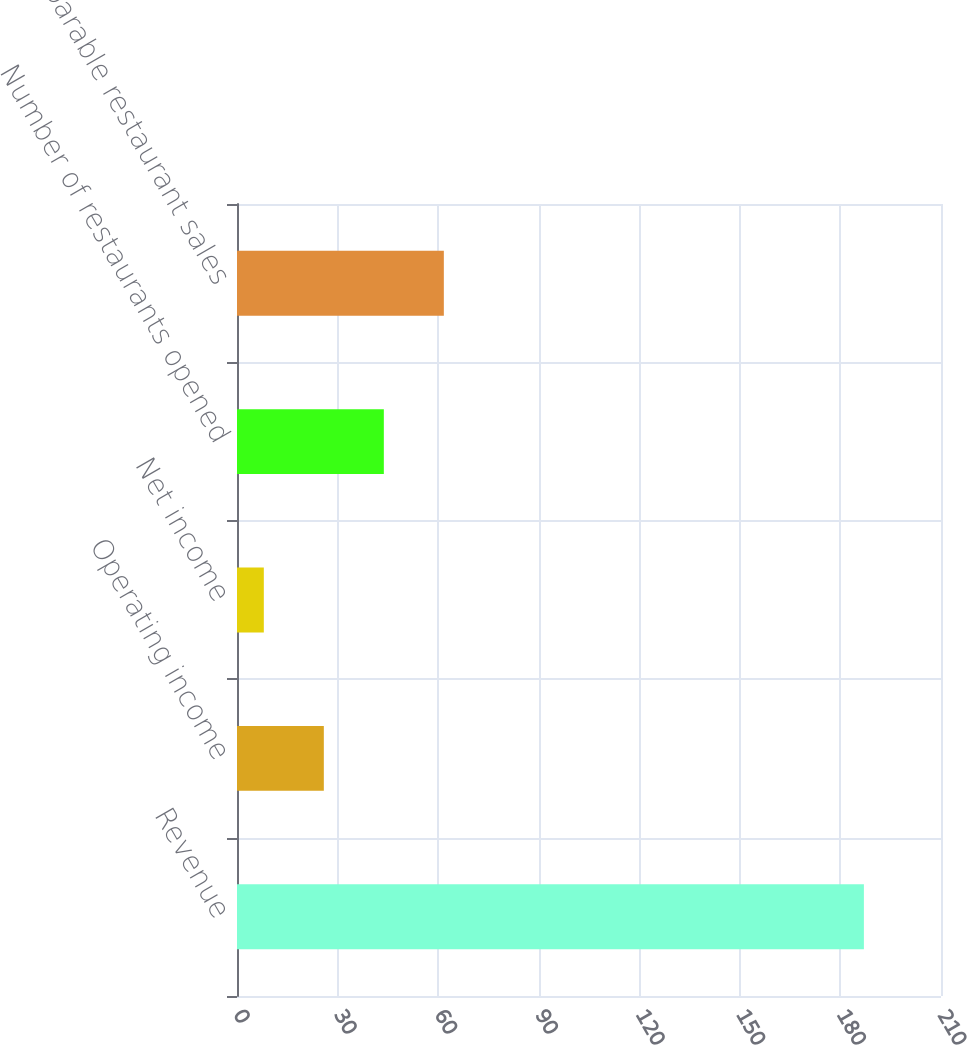Convert chart. <chart><loc_0><loc_0><loc_500><loc_500><bar_chart><fcel>Revenue<fcel>Operating income<fcel>Net income<fcel>Number of restaurants opened<fcel>Comparable restaurant sales<nl><fcel>187<fcel>25.9<fcel>8<fcel>43.8<fcel>61.7<nl></chart> 